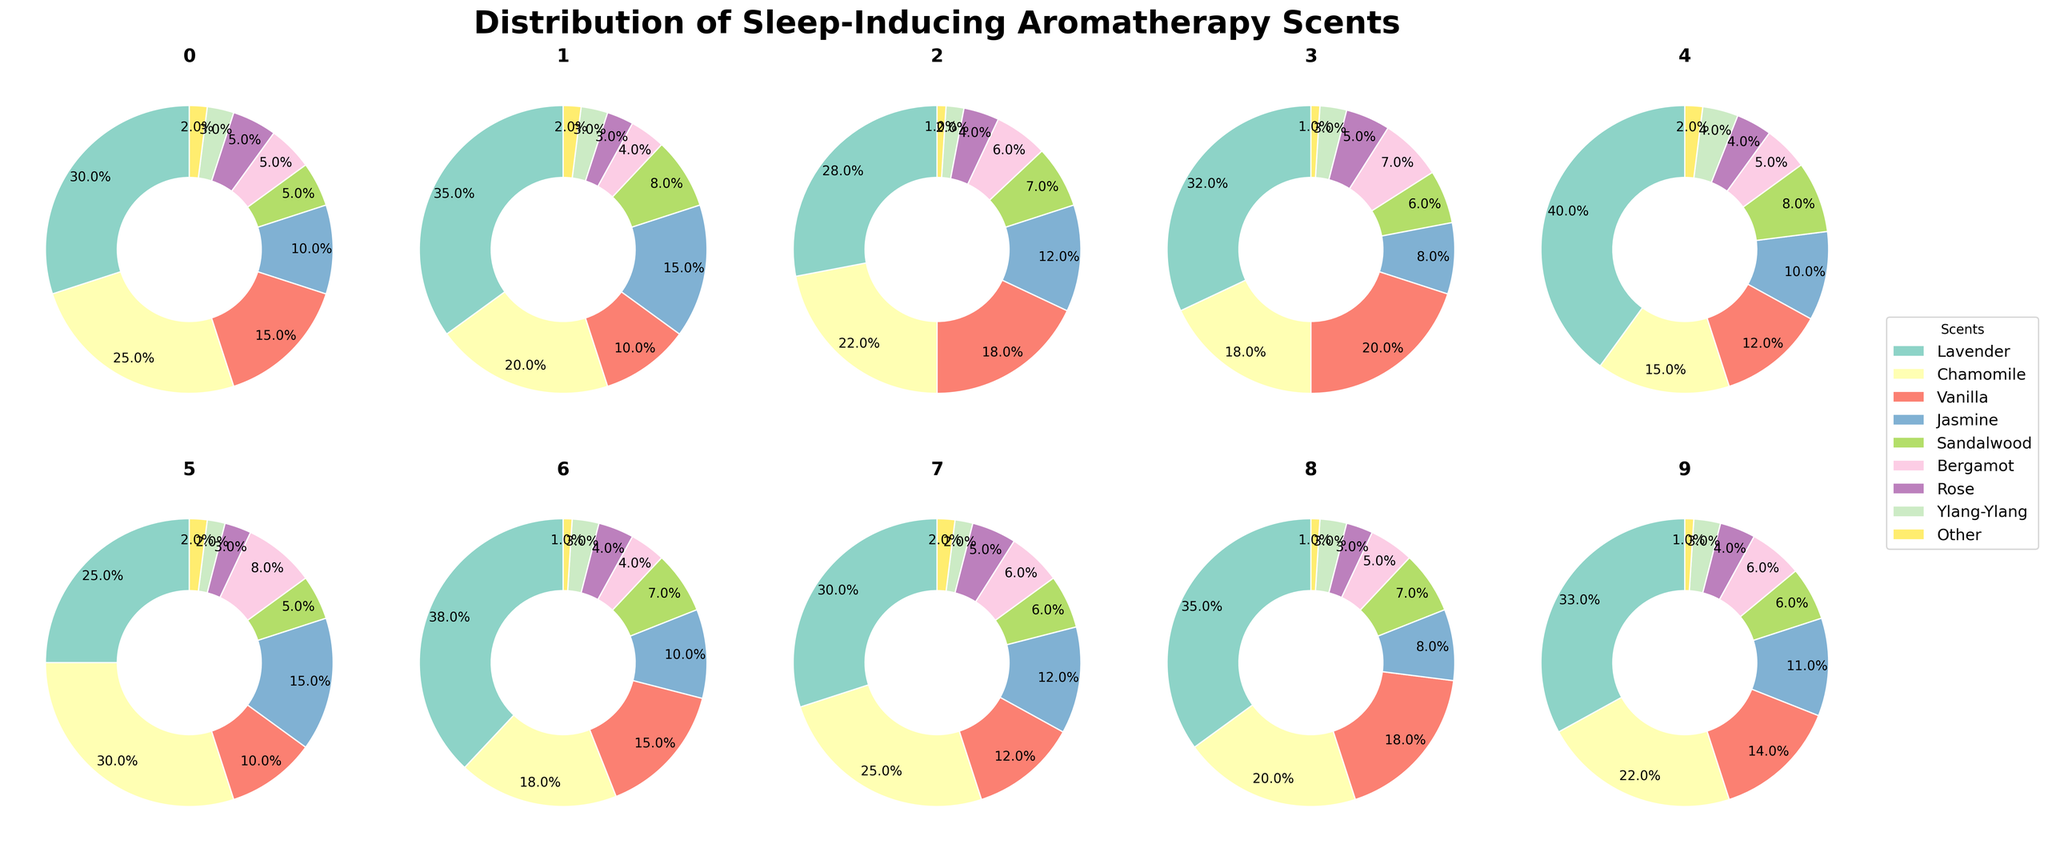What's the most commonly used scent in Bedroom 1? Examine the pie chart for Bedroom 1. Lavender has the largest section.
Answer: Lavender In Bedroom 6, which scent is used more, Bergamot or Ylang-Ylang? Check the pie chart for Bedroom 6 and compare the sections for Bergamot and Ylang-Ylang. Bergamot has a larger section.
Answer: Bergamot Which bedroom uses the highest percentage of Chamomile? Look at all the pie charts and compare the sections for Chamomile. Bedroom 6 has the largest section for Chamomile at 30%.
Answer: Bedroom 6 What's the combined percentage of Lavender and Vanilla in Bedroom 4? Add the percentages of Lavender (32%) and Vanilla (20%) from the Bedroom 4 pie chart. 32% + 20% = 52%
Answer: 52% What is the least used scent in Bedroom 10? Check the pie chart for Bedroom 10. The smallest section corresponds to Other.
Answer: Other Which scent is used less frequently in Bedroom 2, Jasmine or Sandalwood? Look at the sections for Jasmine and Sandalwood in Bedroom 2's pie chart. Sandalwood is smaller at 8% compared to Jasmine at 15%.
Answer: Sandalwood How does the use of Rose in Bedroom 7 compare to its usage in Bedroom 9? Compare the sections for Rose in Bedrooms 7 and 9. Both are the same size at 4%.
Answer: Equal Which two bedrooms have an equal usage of Other? Identify the percentages for Other in all pie charts. Bedroom 2 and Bedroom 6 both have Other at 2%.
Answer: Bedroom 2 and Bedroom 6 Which bedroom has the highest combined usage of Jasmine and Sandalwood? Sum the percentages of Jasmine and Sandalwood in all bedroom pie charts. Bedroom 2 has the highest total: Jasmine (15%) + Sandalwood (8%) = 23%
Answer: Bedroom 2 